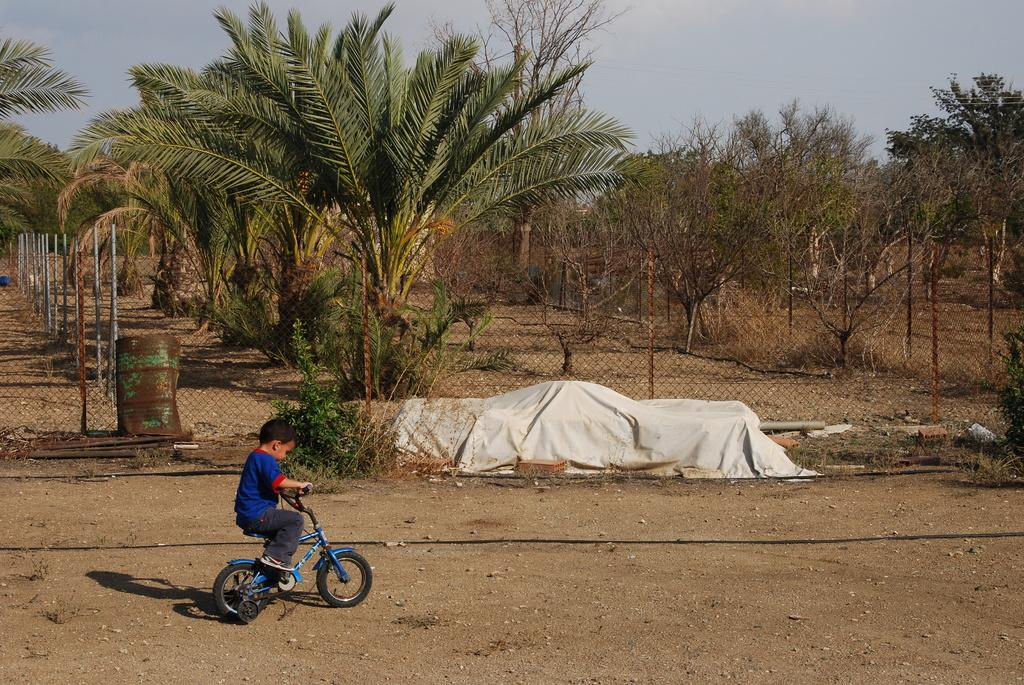Who is the main subject in the image? There is a boy in the image. What is the boy doing in the image? The boy is riding a cycle. What can be seen in the background of the image? There are trees, fencing with a mesh, and the sky visible in the background of the image. What is the color of the sheet in the image? The fact provided does not mention the color of the sheet. What type of liquid is leaking from the hole in the truck in the image? There is no truck or hole present in the image; it features a boy riding a cycle with a background of trees, fencing with a mesh, and the sky. 